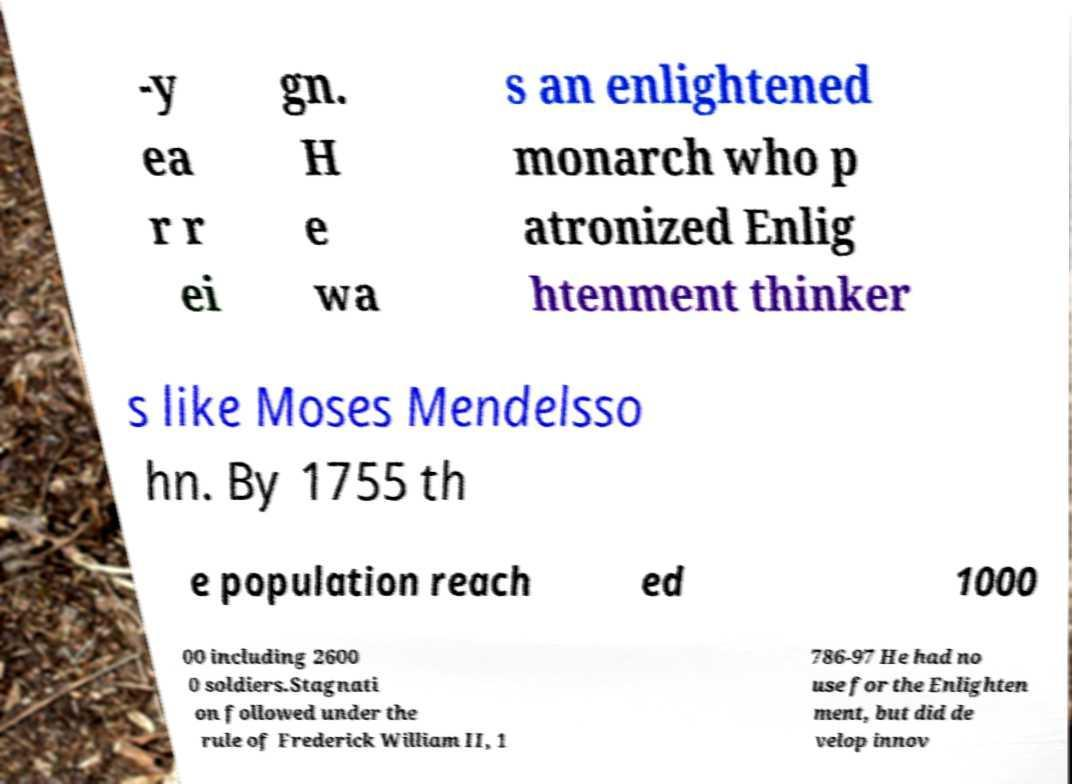Can you accurately transcribe the text from the provided image for me? -y ea r r ei gn. H e wa s an enlightened monarch who p atronized Enlig htenment thinker s like Moses Mendelsso hn. By 1755 th e population reach ed 1000 00 including 2600 0 soldiers.Stagnati on followed under the rule of Frederick William II, 1 786-97 He had no use for the Enlighten ment, but did de velop innov 